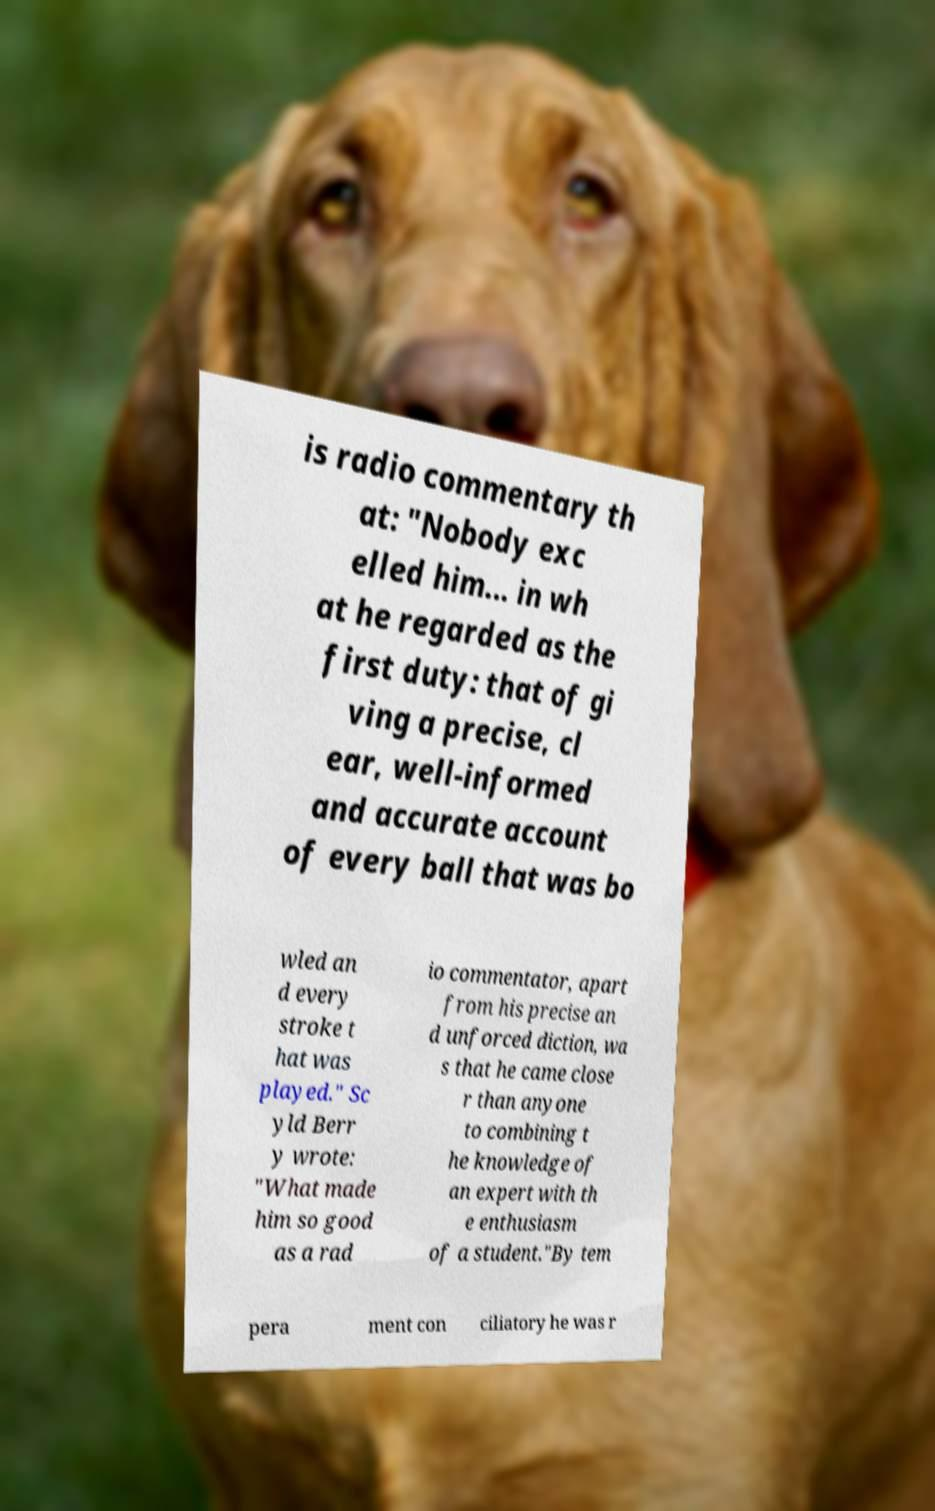There's text embedded in this image that I need extracted. Can you transcribe it verbatim? is radio commentary th at: "Nobody exc elled him... in wh at he regarded as the first duty: that of gi ving a precise, cl ear, well-informed and accurate account of every ball that was bo wled an d every stroke t hat was played." Sc yld Berr y wrote: "What made him so good as a rad io commentator, apart from his precise an d unforced diction, wa s that he came close r than anyone to combining t he knowledge of an expert with th e enthusiasm of a student."By tem pera ment con ciliatory he was r 